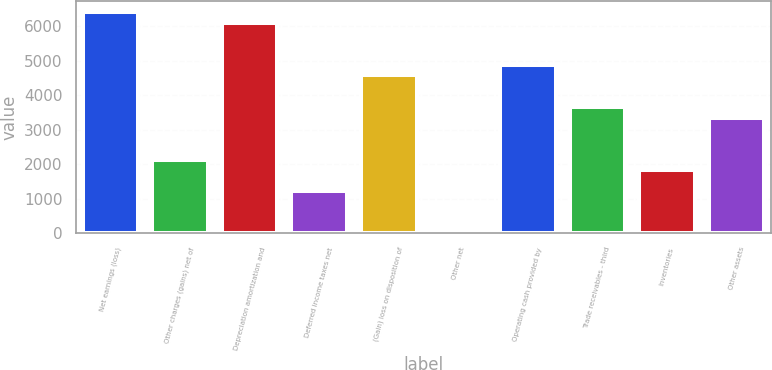Convert chart to OTSL. <chart><loc_0><loc_0><loc_500><loc_500><bar_chart><fcel>Net earnings (loss)<fcel>Other charges (gains) net of<fcel>Depreciation amortization and<fcel>Deferred income taxes net<fcel>(Gain) loss on disposition of<fcel>Other net<fcel>Operating cash provided by<fcel>Trade receivables - third<fcel>Inventories<fcel>Other assets<nl><fcel>6409.1<fcel>2137.7<fcel>6104<fcel>1222.4<fcel>4578.5<fcel>2<fcel>4883.6<fcel>3663.2<fcel>1832.6<fcel>3358.1<nl></chart> 